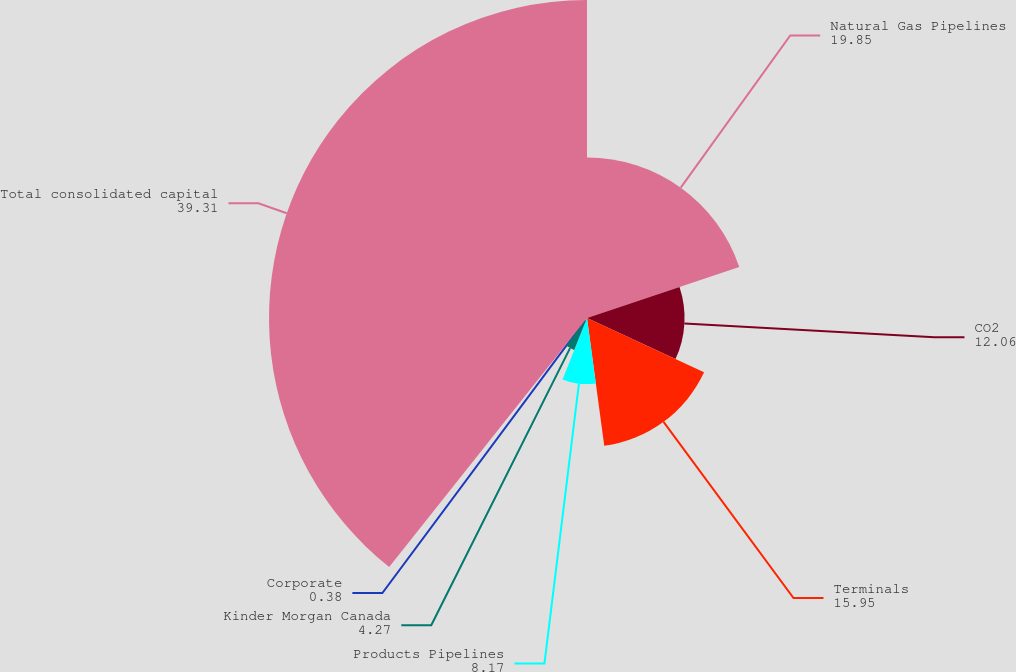Convert chart to OTSL. <chart><loc_0><loc_0><loc_500><loc_500><pie_chart><fcel>Natural Gas Pipelines<fcel>CO2<fcel>Terminals<fcel>Products Pipelines<fcel>Kinder Morgan Canada<fcel>Corporate<fcel>Total consolidated capital<nl><fcel>19.85%<fcel>12.06%<fcel>15.95%<fcel>8.17%<fcel>4.27%<fcel>0.38%<fcel>39.31%<nl></chart> 